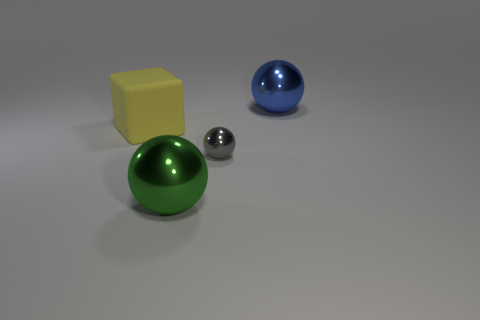There is a large ball that is right of the big metallic sphere that is in front of the tiny gray shiny object; is there a yellow cube on the right side of it? Based on the image, the description of the large ball to the right of the big metallic sphere is accurate. Directly in front of the metallic sphere lies a tiny, shiny gray object. Regarding the yellow cube, it is indeed present and positioned to the left of the metallic sphere, and not on the right side as implied by the question. 